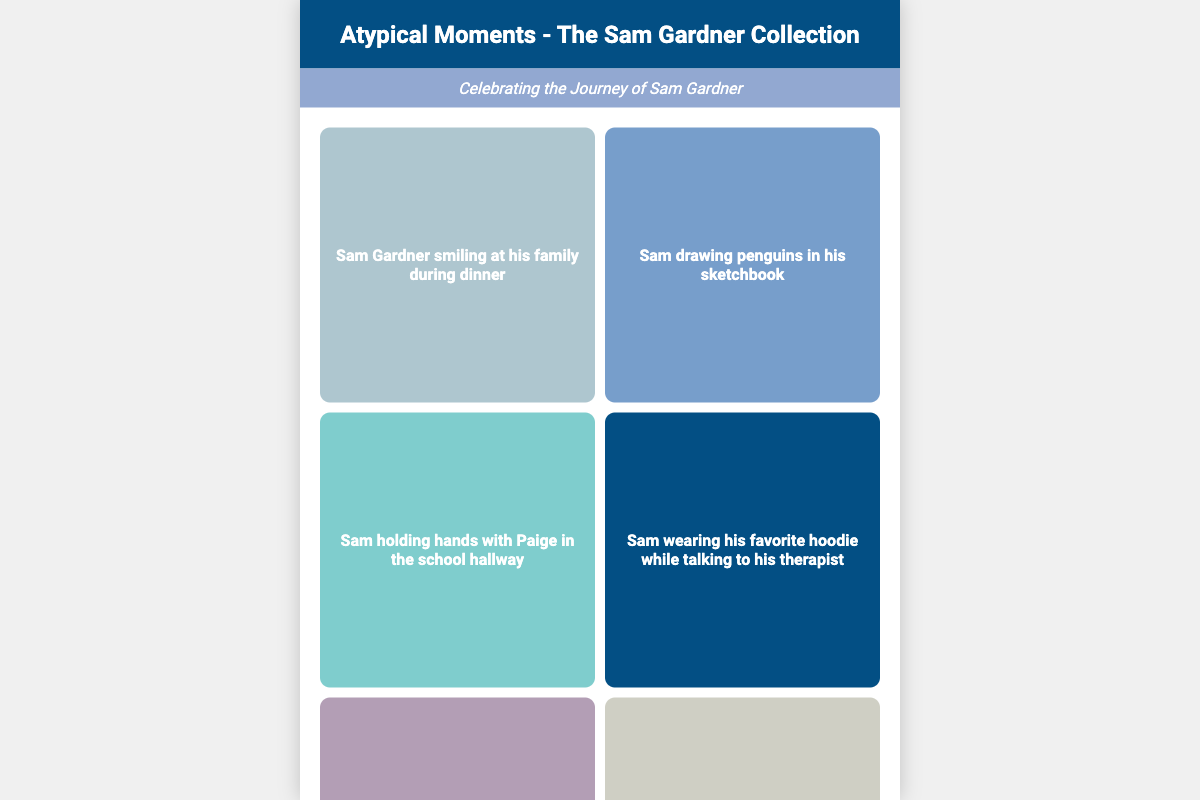What is the title of the book? The title of the book is prominently displayed at the top of the cover.
Answer: Atypical Moments - The Sam Gardner Collection Who is the author of the book? The author is mentioned at the bottom of the cover in an italicized format.
Answer: By: A Fan of Atypical How many snapshots of Sam are included? The grid layout shows there are a total of eight snapshots.
Answer: 8 What is the color of the title background? The title background is a specific color mentioned in the style section of the document.
Answer: #034F84 What type of moments are celebrated in the book? The subtitle describes the kind of moments represented in the book.
Answer: The Journey of Sam Gardner Which character is shown experiencing sensory overload? The document includes a snapshot description that mentions this character.
Answer: Sam What is the color theme used for the frames of the snapshots? The frames for the images are described with varying shades of a specific color.
Answer: Blue What special occasion does Sam celebrate in one of the snapshots? The description for one of the snapshots indicates a particular event or celebration.
Answer: His birthday 